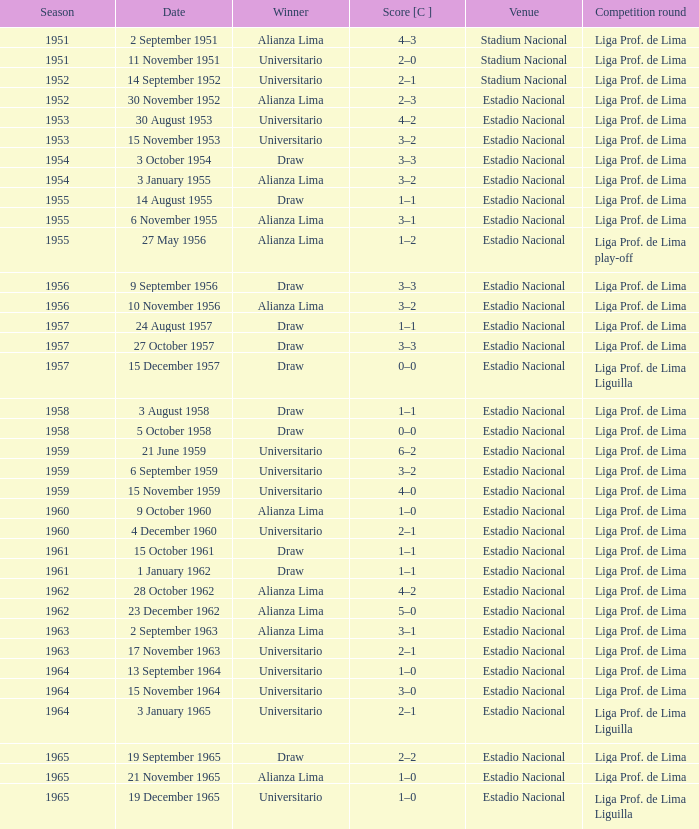Write the full table. {'header': ['Season', 'Date', 'Winner', 'Score [C ]', 'Venue', 'Competition round'], 'rows': [['1951', '2 September 1951', 'Alianza Lima', '4–3', 'Stadium Nacional', 'Liga Prof. de Lima'], ['1951', '11 November 1951', 'Universitario', '2–0', 'Stadium Nacional', 'Liga Prof. de Lima'], ['1952', '14 September 1952', 'Universitario', '2–1', 'Stadium Nacional', 'Liga Prof. de Lima'], ['1952', '30 November 1952', 'Alianza Lima', '2–3', 'Estadio Nacional', 'Liga Prof. de Lima'], ['1953', '30 August 1953', 'Universitario', '4–2', 'Estadio Nacional', 'Liga Prof. de Lima'], ['1953', '15 November 1953', 'Universitario', '3–2', 'Estadio Nacional', 'Liga Prof. de Lima'], ['1954', '3 October 1954', 'Draw', '3–3', 'Estadio Nacional', 'Liga Prof. de Lima'], ['1954', '3 January 1955', 'Alianza Lima', '3–2', 'Estadio Nacional', 'Liga Prof. de Lima'], ['1955', '14 August 1955', 'Draw', '1–1', 'Estadio Nacional', 'Liga Prof. de Lima'], ['1955', '6 November 1955', 'Alianza Lima', '3–1', 'Estadio Nacional', 'Liga Prof. de Lima'], ['1955', '27 May 1956', 'Alianza Lima', '1–2', 'Estadio Nacional', 'Liga Prof. de Lima play-off'], ['1956', '9 September 1956', 'Draw', '3–3', 'Estadio Nacional', 'Liga Prof. de Lima'], ['1956', '10 November 1956', 'Alianza Lima', '3–2', 'Estadio Nacional', 'Liga Prof. de Lima'], ['1957', '24 August 1957', 'Draw', '1–1', 'Estadio Nacional', 'Liga Prof. de Lima'], ['1957', '27 October 1957', 'Draw', '3–3', 'Estadio Nacional', 'Liga Prof. de Lima'], ['1957', '15 December 1957', 'Draw', '0–0', 'Estadio Nacional', 'Liga Prof. de Lima Liguilla'], ['1958', '3 August 1958', 'Draw', '1–1', 'Estadio Nacional', 'Liga Prof. de Lima'], ['1958', '5 October 1958', 'Draw', '0–0', 'Estadio Nacional', 'Liga Prof. de Lima'], ['1959', '21 June 1959', 'Universitario', '6–2', 'Estadio Nacional', 'Liga Prof. de Lima'], ['1959', '6 September 1959', 'Universitario', '3–2', 'Estadio Nacional', 'Liga Prof. de Lima'], ['1959', '15 November 1959', 'Universitario', '4–0', 'Estadio Nacional', 'Liga Prof. de Lima'], ['1960', '9 October 1960', 'Alianza Lima', '1–0', 'Estadio Nacional', 'Liga Prof. de Lima'], ['1960', '4 December 1960', 'Universitario', '2–1', 'Estadio Nacional', 'Liga Prof. de Lima'], ['1961', '15 October 1961', 'Draw', '1–1', 'Estadio Nacional', 'Liga Prof. de Lima'], ['1961', '1 January 1962', 'Draw', '1–1', 'Estadio Nacional', 'Liga Prof. de Lima'], ['1962', '28 October 1962', 'Alianza Lima', '4–2', 'Estadio Nacional', 'Liga Prof. de Lima'], ['1962', '23 December 1962', 'Alianza Lima', '5–0', 'Estadio Nacional', 'Liga Prof. de Lima'], ['1963', '2 September 1963', 'Alianza Lima', '3–1', 'Estadio Nacional', 'Liga Prof. de Lima'], ['1963', '17 November 1963', 'Universitario', '2–1', 'Estadio Nacional', 'Liga Prof. de Lima'], ['1964', '13 September 1964', 'Universitario', '1–0', 'Estadio Nacional', 'Liga Prof. de Lima'], ['1964', '15 November 1964', 'Universitario', '3–0', 'Estadio Nacional', 'Liga Prof. de Lima'], ['1964', '3 January 1965', 'Universitario', '2–1', 'Estadio Nacional', 'Liga Prof. de Lima Liguilla'], ['1965', '19 September 1965', 'Draw', '2–2', 'Estadio Nacional', 'Liga Prof. de Lima'], ['1965', '21 November 1965', 'Alianza Lima', '1–0', 'Estadio Nacional', 'Liga Prof. de Lima'], ['1965', '19 December 1965', 'Universitario', '1–0', 'Estadio Nacional', 'Liga Prof. de Lima Liguilla']]} What venue had an event on 17 November 1963? Estadio Nacional. 